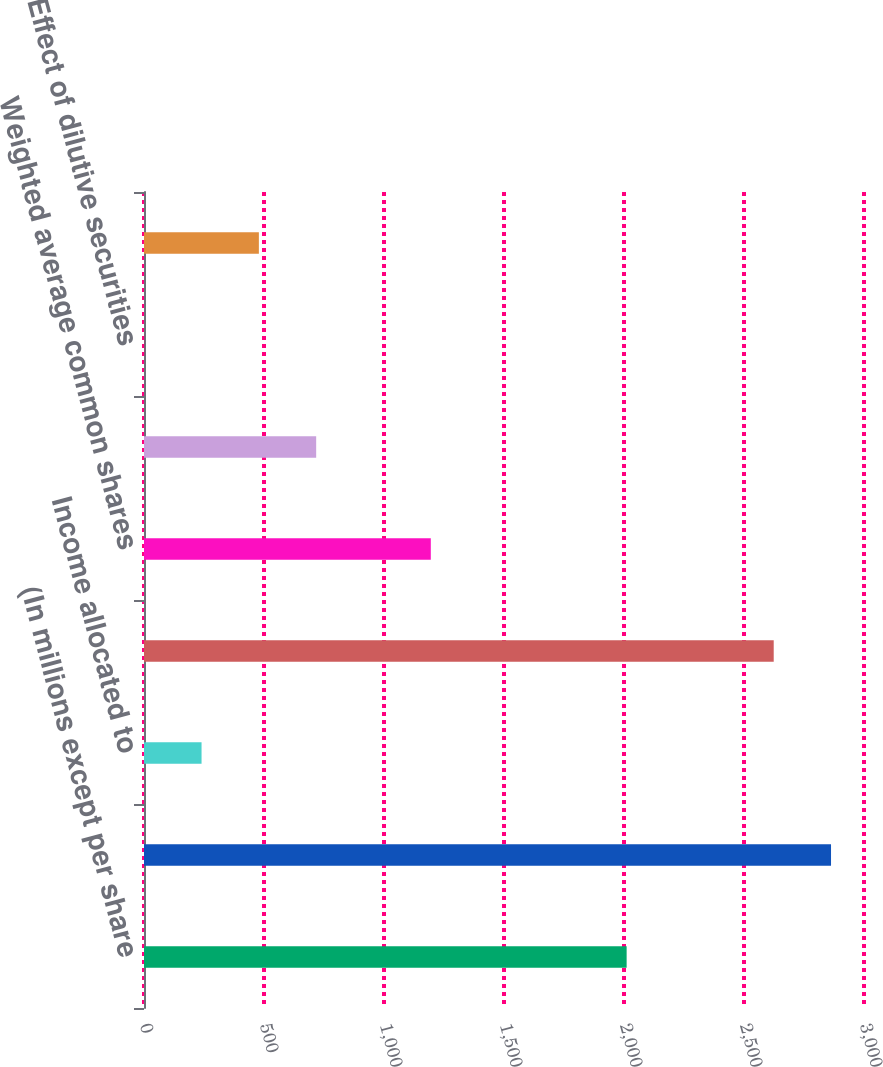<chart> <loc_0><loc_0><loc_500><loc_500><bar_chart><fcel>(In millions except per share<fcel>Net income attributable to MPC<fcel>Income allocated to<fcel>Income available to common<fcel>Weighted average common shares<fcel>Basic earnings per share<fcel>Effect of dilutive securities<fcel>Diluted earnings per share<nl><fcel>2011<fcel>2862.6<fcel>239.8<fcel>2623.8<fcel>1195<fcel>717.4<fcel>1<fcel>478.6<nl></chart> 